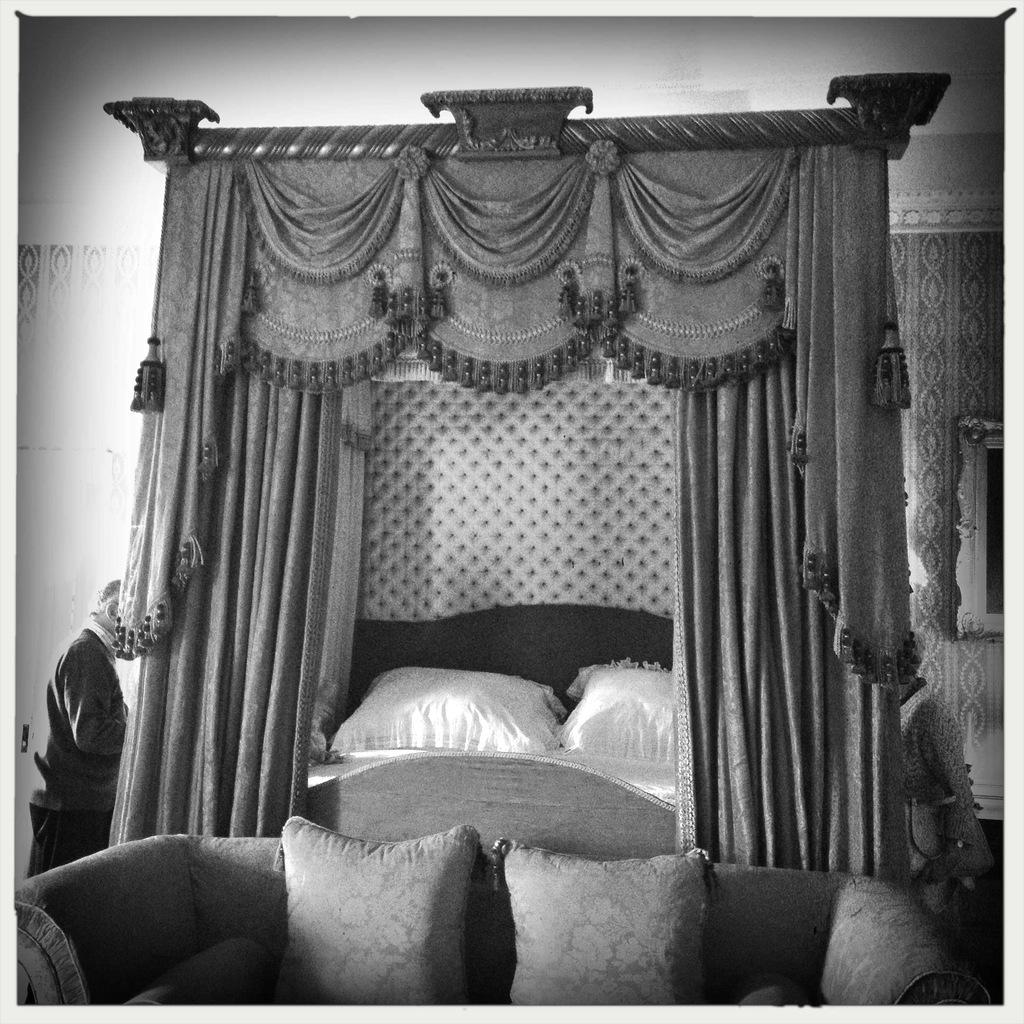Where was the image taken? The image was taken in a bedroom. What furniture can be seen in the background of the image? There is a bed in the background of the image. What is on the bed? The bed has two white pillows on it. What is the main object in the front of the image? There is a sofa in the front of the image. What is visible to the right of the image? There is a wall to the right of the image. What type of shock can be seen on the wall in the image? There is no shock present on the wall in the image. What type of harmony is created by the arrangement of the pillows and sofa in the image? The image does not convey a sense of harmony, as it is a still photograph and does not depict any movement or interaction between the objects. 